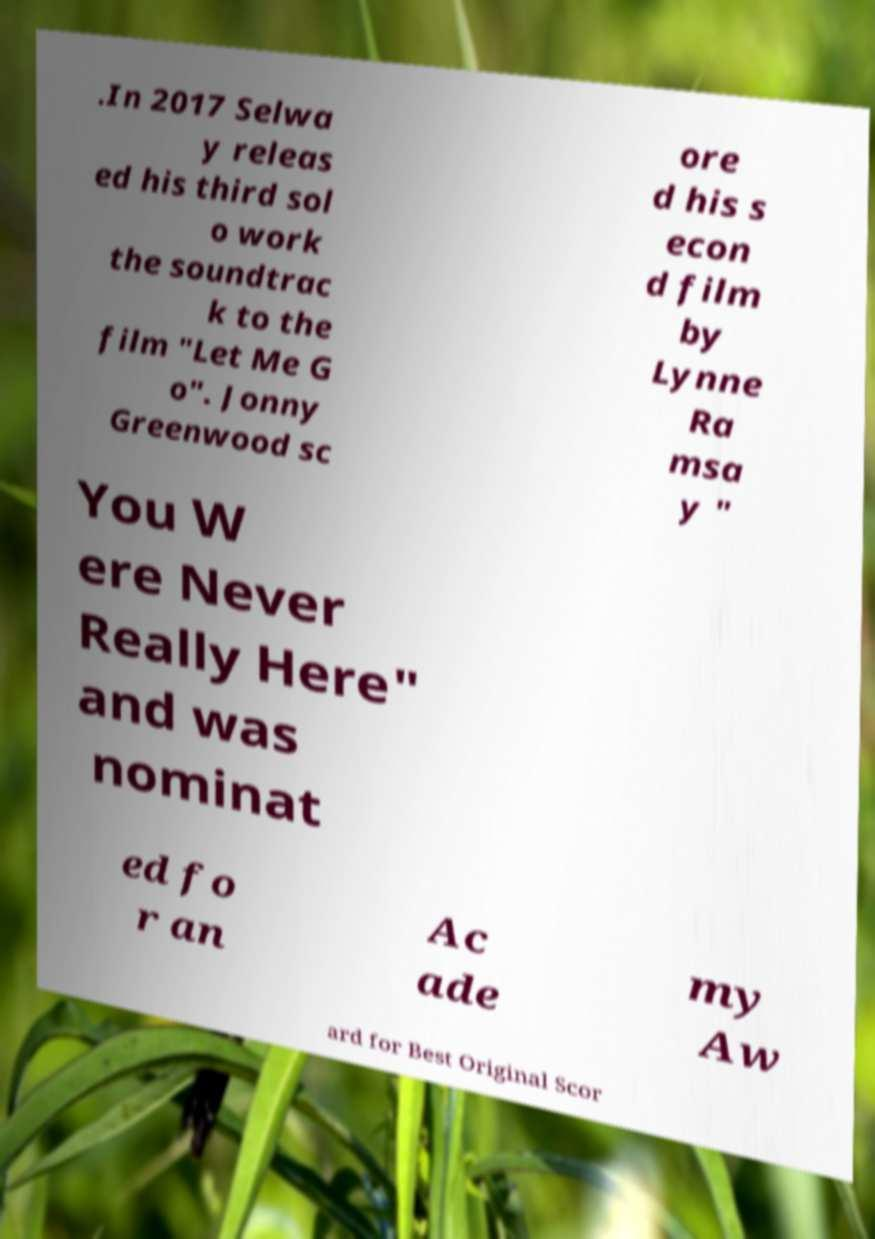I need the written content from this picture converted into text. Can you do that? .In 2017 Selwa y releas ed his third sol o work the soundtrac k to the film "Let Me G o". Jonny Greenwood sc ore d his s econ d film by Lynne Ra msa y " You W ere Never Really Here" and was nominat ed fo r an Ac ade my Aw ard for Best Original Scor 